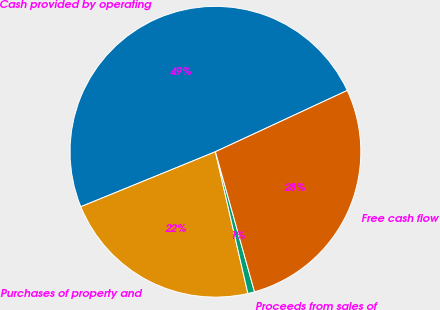Convert chart. <chart><loc_0><loc_0><loc_500><loc_500><pie_chart><fcel>Cash provided by operating<fcel>Purchases of property and<fcel>Proceeds from sales of<fcel>Free cash flow<nl><fcel>49.25%<fcel>22.41%<fcel>0.75%<fcel>27.59%<nl></chart> 